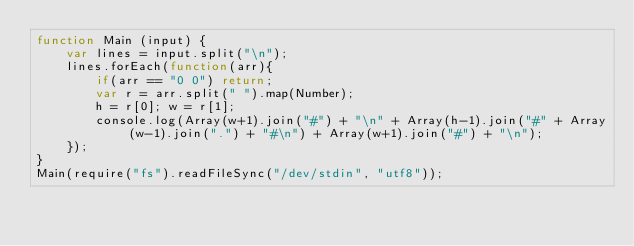Convert code to text. <code><loc_0><loc_0><loc_500><loc_500><_JavaScript_>function Main (input) {
    var lines = input.split("\n");
    lines.forEach(function(arr){
        if(arr == "0 0") return;
        var r = arr.split(" ").map(Number);
        h = r[0]; w = r[1];
        console.log(Array(w+1).join("#") + "\n" + Array(h-1).join("#" + Array(w-1).join(".") + "#\n") + Array(w+1).join("#") + "\n");
    });
}
Main(require("fs").readFileSync("/dev/stdin", "utf8"));</code> 